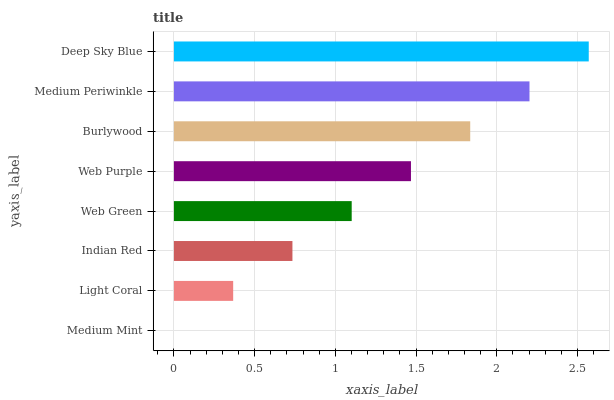Is Medium Mint the minimum?
Answer yes or no. Yes. Is Deep Sky Blue the maximum?
Answer yes or no. Yes. Is Light Coral the minimum?
Answer yes or no. No. Is Light Coral the maximum?
Answer yes or no. No. Is Light Coral greater than Medium Mint?
Answer yes or no. Yes. Is Medium Mint less than Light Coral?
Answer yes or no. Yes. Is Medium Mint greater than Light Coral?
Answer yes or no. No. Is Light Coral less than Medium Mint?
Answer yes or no. No. Is Web Purple the high median?
Answer yes or no. Yes. Is Web Green the low median?
Answer yes or no. Yes. Is Light Coral the high median?
Answer yes or no. No. Is Deep Sky Blue the low median?
Answer yes or no. No. 